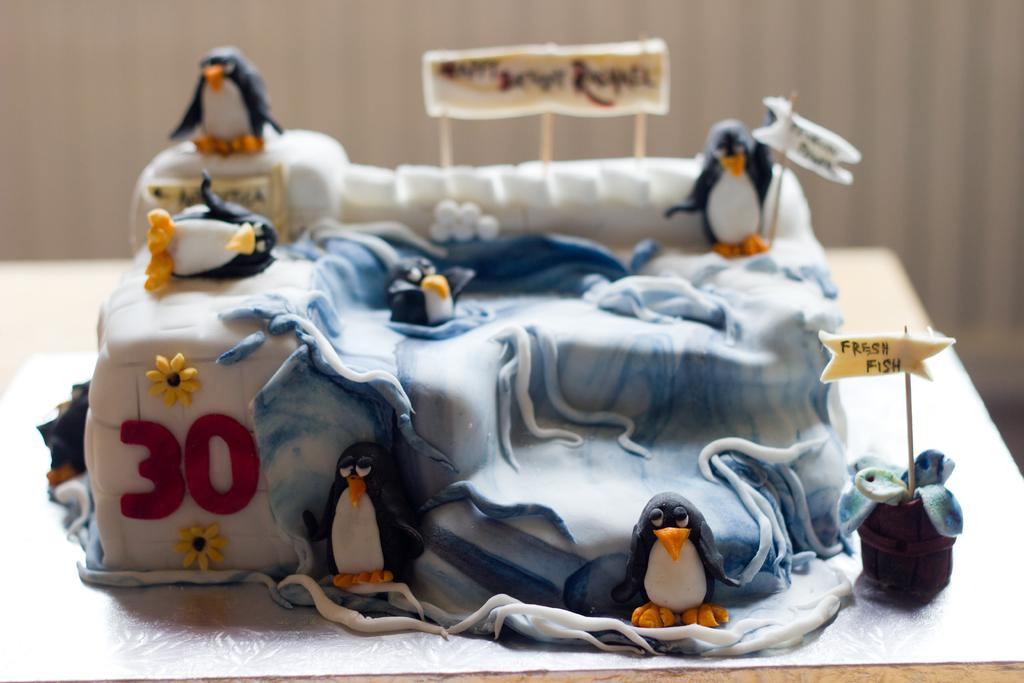What is the main subject of the image? There is a birthday cake in the image. Where is the cake located in the image? The cake is in the center of the image. What is written on the cake? There is text written on the cake. What decorations are on the cake? There are penguin models on the cake. How long did the daughter's voyage take to reach the quarter in the image? There is no daughter, voyage, or quarter mentioned or depicted in the image; it features a birthday cake with penguin models and text. 